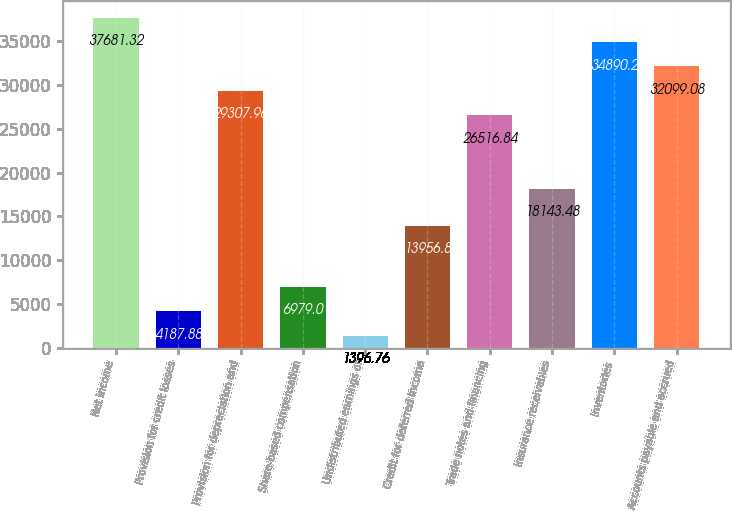Convert chart to OTSL. <chart><loc_0><loc_0><loc_500><loc_500><bar_chart><fcel>Net income<fcel>Provision for credit losses<fcel>Provision for depreciation and<fcel>Share-based compensation<fcel>Undistributed earnings of<fcel>Credit for deferred income<fcel>Trade notes and financing<fcel>Insurance receivables<fcel>Inventories<fcel>Accounts payable and accrued<nl><fcel>37681.3<fcel>4187.88<fcel>29308<fcel>6979<fcel>1396.76<fcel>13956.8<fcel>26516.8<fcel>18143.5<fcel>34890.2<fcel>32099.1<nl></chart> 